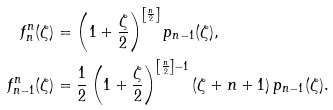Convert formula to latex. <formula><loc_0><loc_0><loc_500><loc_500>f ^ { n } _ { n } ( \zeta ) & = \left ( 1 + \frac { \zeta } { 2 } \right ) ^ { \left [ \frac { n } { 2 } \right ] } p _ { n - 1 } ( \zeta ) , \\ f _ { n - 1 } ^ { n } ( \zeta ) & = \frac { 1 } { 2 } \left ( 1 + \frac { \zeta } { 2 } \right ) ^ { \left [ \frac { n } { 2 } \right ] - 1 } ( \zeta + n + 1 ) \, p _ { n - 1 } ( \zeta ) .</formula> 